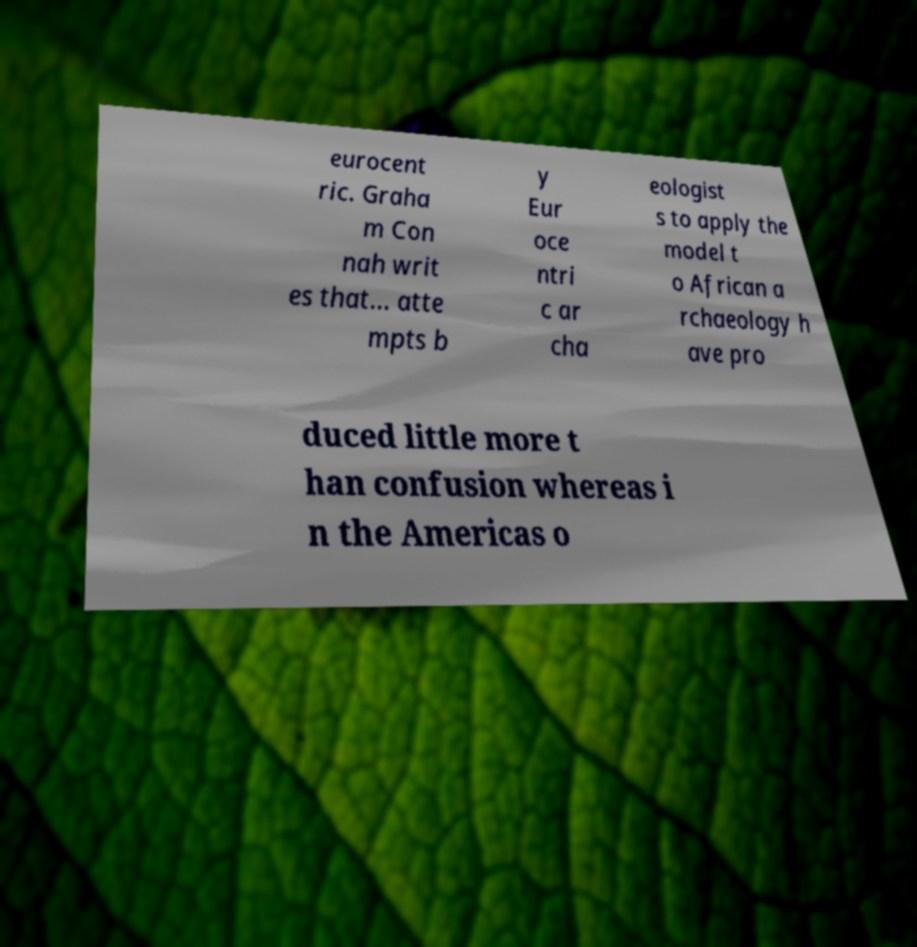What messages or text are displayed in this image? I need them in a readable, typed format. eurocent ric. Graha m Con nah writ es that... atte mpts b y Eur oce ntri c ar cha eologist s to apply the model t o African a rchaeology h ave pro duced little more t han confusion whereas i n the Americas o 